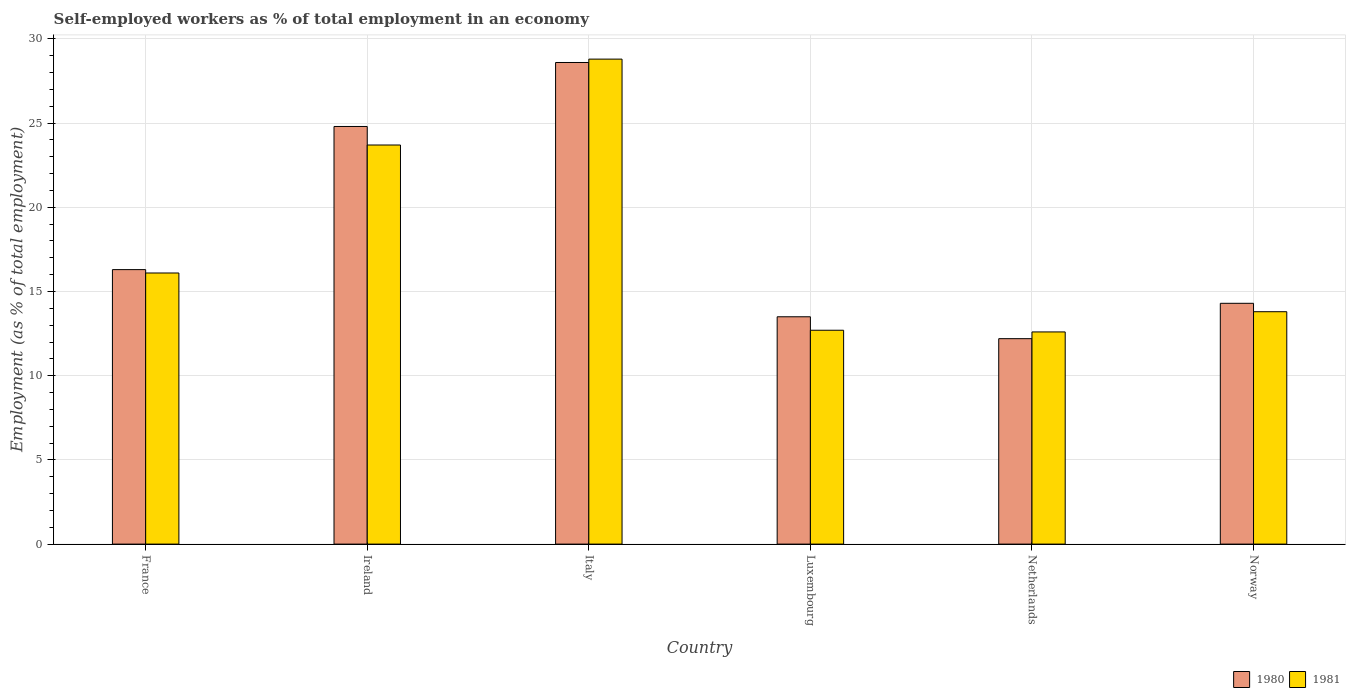How many different coloured bars are there?
Keep it short and to the point. 2. How many groups of bars are there?
Give a very brief answer. 6. Are the number of bars per tick equal to the number of legend labels?
Your answer should be very brief. Yes. Are the number of bars on each tick of the X-axis equal?
Your answer should be compact. Yes. How many bars are there on the 3rd tick from the left?
Ensure brevity in your answer.  2. What is the percentage of self-employed workers in 1981 in Luxembourg?
Your response must be concise. 12.7. Across all countries, what is the maximum percentage of self-employed workers in 1981?
Offer a very short reply. 28.8. Across all countries, what is the minimum percentage of self-employed workers in 1981?
Give a very brief answer. 12.6. In which country was the percentage of self-employed workers in 1981 maximum?
Provide a short and direct response. Italy. In which country was the percentage of self-employed workers in 1980 minimum?
Provide a short and direct response. Netherlands. What is the total percentage of self-employed workers in 1981 in the graph?
Your answer should be compact. 107.7. What is the difference between the percentage of self-employed workers in 1980 in France and that in Ireland?
Provide a short and direct response. -8.5. What is the difference between the percentage of self-employed workers in 1980 in Luxembourg and the percentage of self-employed workers in 1981 in France?
Your answer should be very brief. -2.6. What is the average percentage of self-employed workers in 1981 per country?
Your answer should be very brief. 17.95. What is the difference between the percentage of self-employed workers of/in 1980 and percentage of self-employed workers of/in 1981 in Ireland?
Keep it short and to the point. 1.1. In how many countries, is the percentage of self-employed workers in 1980 greater than 23 %?
Make the answer very short. 2. What is the ratio of the percentage of self-employed workers in 1980 in Ireland to that in Luxembourg?
Give a very brief answer. 1.84. Is the difference between the percentage of self-employed workers in 1980 in Ireland and Netherlands greater than the difference between the percentage of self-employed workers in 1981 in Ireland and Netherlands?
Your answer should be very brief. Yes. What is the difference between the highest and the lowest percentage of self-employed workers in 1980?
Keep it short and to the point. 16.4. What does the 1st bar from the right in Italy represents?
Provide a short and direct response. 1981. Are all the bars in the graph horizontal?
Provide a succinct answer. No. How many countries are there in the graph?
Make the answer very short. 6. What is the difference between two consecutive major ticks on the Y-axis?
Give a very brief answer. 5. Are the values on the major ticks of Y-axis written in scientific E-notation?
Offer a terse response. No. Does the graph contain any zero values?
Ensure brevity in your answer.  No. Does the graph contain grids?
Offer a very short reply. Yes. Where does the legend appear in the graph?
Your response must be concise. Bottom right. What is the title of the graph?
Give a very brief answer. Self-employed workers as % of total employment in an economy. What is the label or title of the X-axis?
Your answer should be very brief. Country. What is the label or title of the Y-axis?
Your answer should be compact. Employment (as % of total employment). What is the Employment (as % of total employment) in 1980 in France?
Your answer should be very brief. 16.3. What is the Employment (as % of total employment) in 1981 in France?
Your response must be concise. 16.1. What is the Employment (as % of total employment) of 1980 in Ireland?
Provide a succinct answer. 24.8. What is the Employment (as % of total employment) in 1981 in Ireland?
Provide a succinct answer. 23.7. What is the Employment (as % of total employment) of 1980 in Italy?
Give a very brief answer. 28.6. What is the Employment (as % of total employment) of 1981 in Italy?
Provide a short and direct response. 28.8. What is the Employment (as % of total employment) in 1981 in Luxembourg?
Provide a short and direct response. 12.7. What is the Employment (as % of total employment) of 1980 in Netherlands?
Ensure brevity in your answer.  12.2. What is the Employment (as % of total employment) of 1981 in Netherlands?
Offer a very short reply. 12.6. What is the Employment (as % of total employment) of 1980 in Norway?
Give a very brief answer. 14.3. What is the Employment (as % of total employment) of 1981 in Norway?
Keep it short and to the point. 13.8. Across all countries, what is the maximum Employment (as % of total employment) of 1980?
Your response must be concise. 28.6. Across all countries, what is the maximum Employment (as % of total employment) of 1981?
Your answer should be very brief. 28.8. Across all countries, what is the minimum Employment (as % of total employment) in 1980?
Your answer should be compact. 12.2. Across all countries, what is the minimum Employment (as % of total employment) in 1981?
Provide a succinct answer. 12.6. What is the total Employment (as % of total employment) of 1980 in the graph?
Keep it short and to the point. 109.7. What is the total Employment (as % of total employment) in 1981 in the graph?
Provide a short and direct response. 107.7. What is the difference between the Employment (as % of total employment) in 1981 in France and that in Ireland?
Provide a short and direct response. -7.6. What is the difference between the Employment (as % of total employment) in 1981 in France and that in Netherlands?
Provide a succinct answer. 3.5. What is the difference between the Employment (as % of total employment) of 1980 in Ireland and that in Luxembourg?
Provide a succinct answer. 11.3. What is the difference between the Employment (as % of total employment) of 1981 in Ireland and that in Luxembourg?
Offer a very short reply. 11. What is the difference between the Employment (as % of total employment) in 1980 in Ireland and that in Netherlands?
Make the answer very short. 12.6. What is the difference between the Employment (as % of total employment) of 1980 in Ireland and that in Norway?
Give a very brief answer. 10.5. What is the difference between the Employment (as % of total employment) in 1981 in Italy and that in Luxembourg?
Give a very brief answer. 16.1. What is the difference between the Employment (as % of total employment) in 1980 in Italy and that in Netherlands?
Your answer should be very brief. 16.4. What is the difference between the Employment (as % of total employment) in 1980 in Italy and that in Norway?
Ensure brevity in your answer.  14.3. What is the difference between the Employment (as % of total employment) of 1981 in Italy and that in Norway?
Make the answer very short. 15. What is the difference between the Employment (as % of total employment) in 1980 in Luxembourg and that in Netherlands?
Offer a very short reply. 1.3. What is the difference between the Employment (as % of total employment) of 1980 in Luxembourg and that in Norway?
Offer a very short reply. -0.8. What is the difference between the Employment (as % of total employment) in 1981 in Luxembourg and that in Norway?
Provide a succinct answer. -1.1. What is the difference between the Employment (as % of total employment) of 1980 in Netherlands and that in Norway?
Give a very brief answer. -2.1. What is the difference between the Employment (as % of total employment) of 1980 in France and the Employment (as % of total employment) of 1981 in Ireland?
Give a very brief answer. -7.4. What is the difference between the Employment (as % of total employment) of 1980 in France and the Employment (as % of total employment) of 1981 in Luxembourg?
Provide a short and direct response. 3.6. What is the difference between the Employment (as % of total employment) of 1980 in France and the Employment (as % of total employment) of 1981 in Netherlands?
Give a very brief answer. 3.7. What is the difference between the Employment (as % of total employment) in 1980 in France and the Employment (as % of total employment) in 1981 in Norway?
Ensure brevity in your answer.  2.5. What is the difference between the Employment (as % of total employment) of 1980 in Ireland and the Employment (as % of total employment) of 1981 in Italy?
Provide a short and direct response. -4. What is the difference between the Employment (as % of total employment) in 1980 in Ireland and the Employment (as % of total employment) in 1981 in Luxembourg?
Offer a terse response. 12.1. What is the difference between the Employment (as % of total employment) in 1980 in Italy and the Employment (as % of total employment) in 1981 in Luxembourg?
Your answer should be very brief. 15.9. What is the difference between the Employment (as % of total employment) of 1980 in Italy and the Employment (as % of total employment) of 1981 in Netherlands?
Offer a very short reply. 16. What is the difference between the Employment (as % of total employment) of 1980 in Luxembourg and the Employment (as % of total employment) of 1981 in Netherlands?
Provide a succinct answer. 0.9. What is the difference between the Employment (as % of total employment) in 1980 in Luxembourg and the Employment (as % of total employment) in 1981 in Norway?
Offer a terse response. -0.3. What is the average Employment (as % of total employment) of 1980 per country?
Your answer should be very brief. 18.28. What is the average Employment (as % of total employment) of 1981 per country?
Make the answer very short. 17.95. What is the difference between the Employment (as % of total employment) in 1980 and Employment (as % of total employment) in 1981 in Luxembourg?
Make the answer very short. 0.8. What is the ratio of the Employment (as % of total employment) in 1980 in France to that in Ireland?
Offer a terse response. 0.66. What is the ratio of the Employment (as % of total employment) of 1981 in France to that in Ireland?
Your response must be concise. 0.68. What is the ratio of the Employment (as % of total employment) in 1980 in France to that in Italy?
Keep it short and to the point. 0.57. What is the ratio of the Employment (as % of total employment) of 1981 in France to that in Italy?
Your answer should be compact. 0.56. What is the ratio of the Employment (as % of total employment) in 1980 in France to that in Luxembourg?
Provide a short and direct response. 1.21. What is the ratio of the Employment (as % of total employment) in 1981 in France to that in Luxembourg?
Provide a succinct answer. 1.27. What is the ratio of the Employment (as % of total employment) in 1980 in France to that in Netherlands?
Offer a terse response. 1.34. What is the ratio of the Employment (as % of total employment) of 1981 in France to that in Netherlands?
Keep it short and to the point. 1.28. What is the ratio of the Employment (as % of total employment) in 1980 in France to that in Norway?
Offer a terse response. 1.14. What is the ratio of the Employment (as % of total employment) of 1980 in Ireland to that in Italy?
Provide a short and direct response. 0.87. What is the ratio of the Employment (as % of total employment) in 1981 in Ireland to that in Italy?
Your response must be concise. 0.82. What is the ratio of the Employment (as % of total employment) in 1980 in Ireland to that in Luxembourg?
Give a very brief answer. 1.84. What is the ratio of the Employment (as % of total employment) of 1981 in Ireland to that in Luxembourg?
Keep it short and to the point. 1.87. What is the ratio of the Employment (as % of total employment) of 1980 in Ireland to that in Netherlands?
Provide a succinct answer. 2.03. What is the ratio of the Employment (as % of total employment) in 1981 in Ireland to that in Netherlands?
Give a very brief answer. 1.88. What is the ratio of the Employment (as % of total employment) of 1980 in Ireland to that in Norway?
Keep it short and to the point. 1.73. What is the ratio of the Employment (as % of total employment) in 1981 in Ireland to that in Norway?
Offer a terse response. 1.72. What is the ratio of the Employment (as % of total employment) in 1980 in Italy to that in Luxembourg?
Keep it short and to the point. 2.12. What is the ratio of the Employment (as % of total employment) of 1981 in Italy to that in Luxembourg?
Make the answer very short. 2.27. What is the ratio of the Employment (as % of total employment) of 1980 in Italy to that in Netherlands?
Keep it short and to the point. 2.34. What is the ratio of the Employment (as % of total employment) in 1981 in Italy to that in Netherlands?
Your response must be concise. 2.29. What is the ratio of the Employment (as % of total employment) in 1981 in Italy to that in Norway?
Ensure brevity in your answer.  2.09. What is the ratio of the Employment (as % of total employment) of 1980 in Luxembourg to that in Netherlands?
Offer a terse response. 1.11. What is the ratio of the Employment (as % of total employment) of 1981 in Luxembourg to that in Netherlands?
Your answer should be compact. 1.01. What is the ratio of the Employment (as % of total employment) in 1980 in Luxembourg to that in Norway?
Offer a very short reply. 0.94. What is the ratio of the Employment (as % of total employment) of 1981 in Luxembourg to that in Norway?
Keep it short and to the point. 0.92. What is the ratio of the Employment (as % of total employment) of 1980 in Netherlands to that in Norway?
Make the answer very short. 0.85. What is the ratio of the Employment (as % of total employment) of 1981 in Netherlands to that in Norway?
Ensure brevity in your answer.  0.91. What is the difference between the highest and the second highest Employment (as % of total employment) of 1980?
Your response must be concise. 3.8. What is the difference between the highest and the lowest Employment (as % of total employment) in 1980?
Provide a succinct answer. 16.4. 